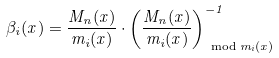Convert formula to latex. <formula><loc_0><loc_0><loc_500><loc_500>\beta _ { i } ( x ) = \frac { M _ { n } ( x ) } { m _ { i } ( x ) } \cdot \left ( \frac { M _ { n } ( x ) } { m _ { i } ( x ) } \right ) _ { \, \bmod m _ { i } ( x ) } ^ { - 1 }</formula> 